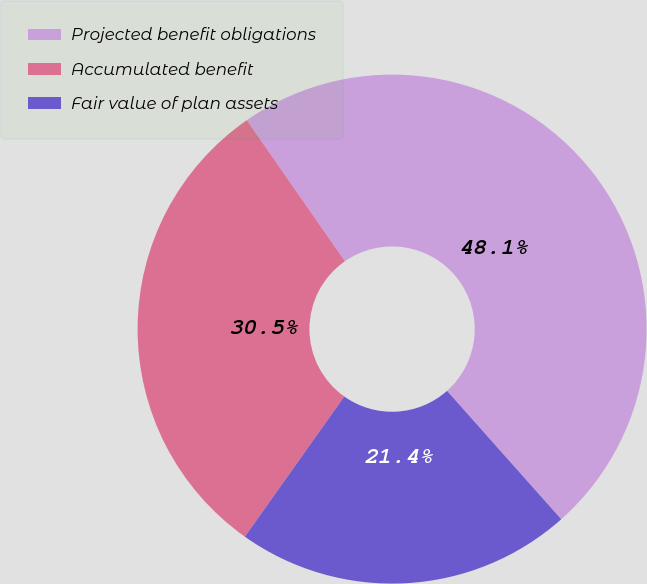Convert chart to OTSL. <chart><loc_0><loc_0><loc_500><loc_500><pie_chart><fcel>Projected benefit obligations<fcel>Accumulated benefit<fcel>Fair value of plan assets<nl><fcel>48.1%<fcel>30.51%<fcel>21.39%<nl></chart> 